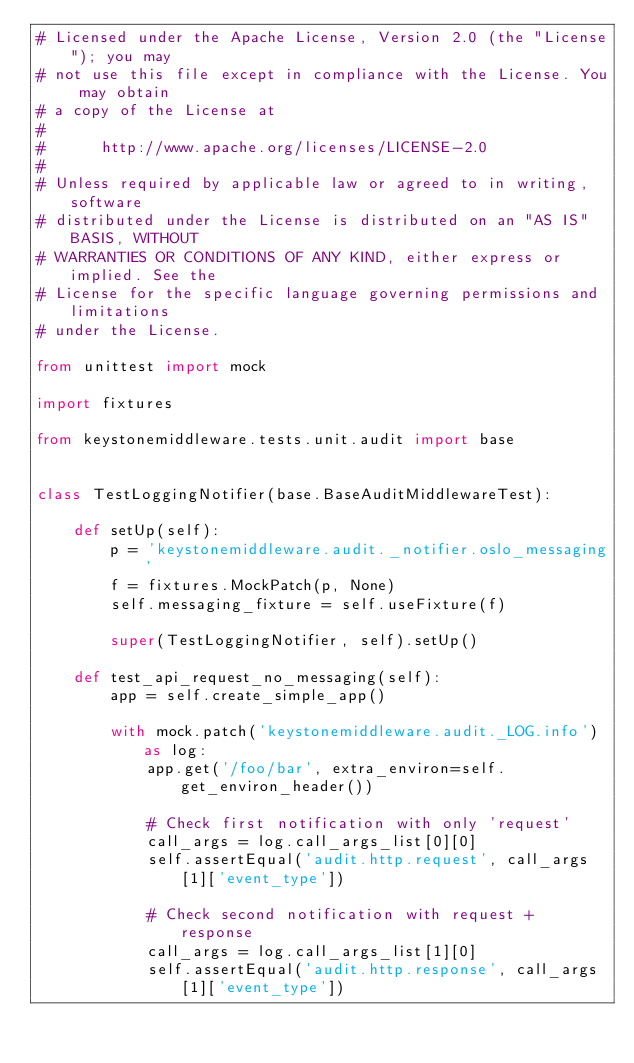Convert code to text. <code><loc_0><loc_0><loc_500><loc_500><_Python_># Licensed under the Apache License, Version 2.0 (the "License"); you may
# not use this file except in compliance with the License. You may obtain
# a copy of the License at
#
#      http://www.apache.org/licenses/LICENSE-2.0
#
# Unless required by applicable law or agreed to in writing, software
# distributed under the License is distributed on an "AS IS" BASIS, WITHOUT
# WARRANTIES OR CONDITIONS OF ANY KIND, either express or implied. See the
# License for the specific language governing permissions and limitations
# under the License.

from unittest import mock

import fixtures

from keystonemiddleware.tests.unit.audit import base


class TestLoggingNotifier(base.BaseAuditMiddlewareTest):

    def setUp(self):
        p = 'keystonemiddleware.audit._notifier.oslo_messaging'
        f = fixtures.MockPatch(p, None)
        self.messaging_fixture = self.useFixture(f)

        super(TestLoggingNotifier, self).setUp()

    def test_api_request_no_messaging(self):
        app = self.create_simple_app()

        with mock.patch('keystonemiddleware.audit._LOG.info') as log:
            app.get('/foo/bar', extra_environ=self.get_environ_header())

            # Check first notification with only 'request'
            call_args = log.call_args_list[0][0]
            self.assertEqual('audit.http.request', call_args[1]['event_type'])

            # Check second notification with request + response
            call_args = log.call_args_list[1][0]
            self.assertEqual('audit.http.response', call_args[1]['event_type'])
</code> 